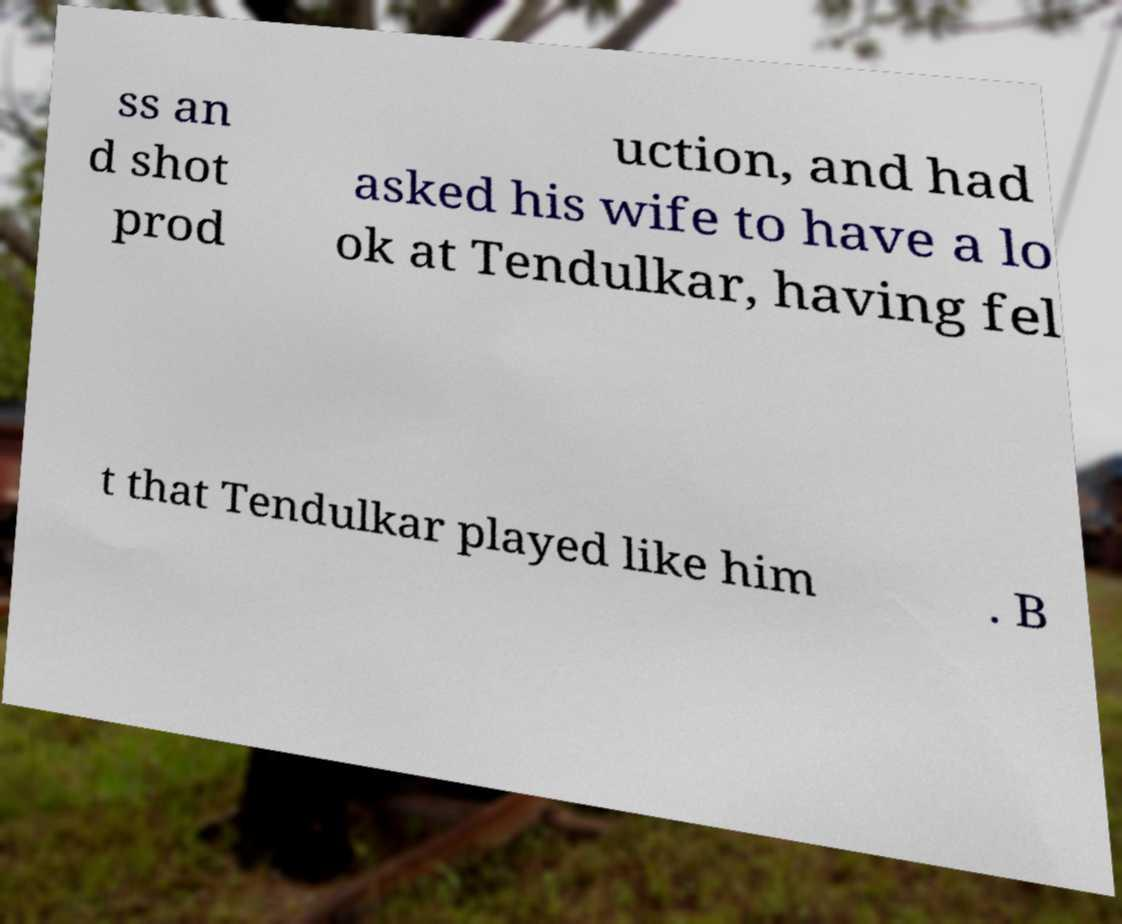Could you assist in decoding the text presented in this image and type it out clearly? ss an d shot prod uction, and had asked his wife to have a lo ok at Tendulkar, having fel t that Tendulkar played like him . B 